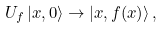Convert formula to latex. <formula><loc_0><loc_0><loc_500><loc_500>U _ { f } \left | { x , 0 } \right \rangle \to \left | { x , f ( x ) } \right \rangle ,</formula> 